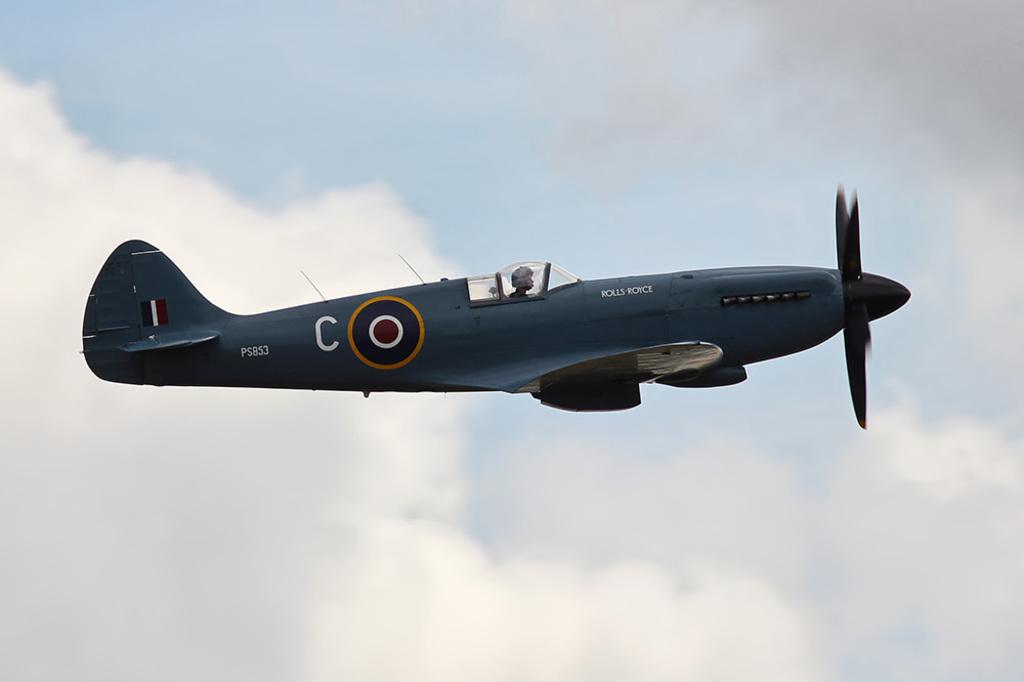What letter is to the left of the bulls eye?
Ensure brevity in your answer.  C. What letter is inside the bullseye?
Your response must be concise. O. 